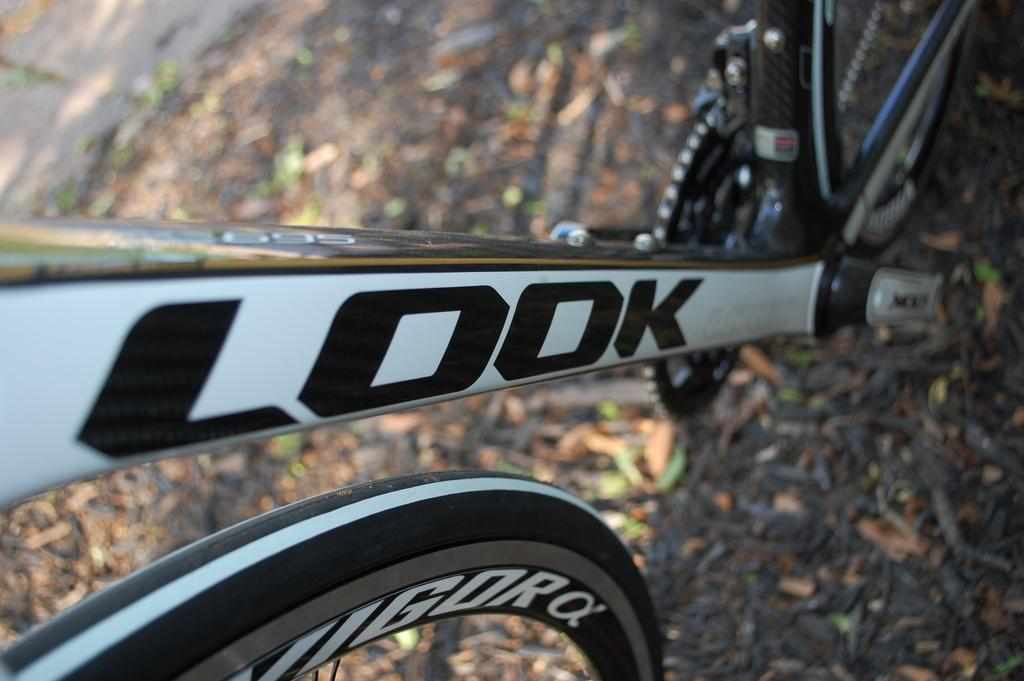What is the main subject in the center of the image? There is a cycle in the center of the image. Are there any words or letters on the cycle? Yes, the cycle has some text on it. Can you describe the background of the image? The background of the image is blurred. What type of weather can be seen in the image? There is no weather visible in the image, as the background is blurred and does not show any outdoor elements. 